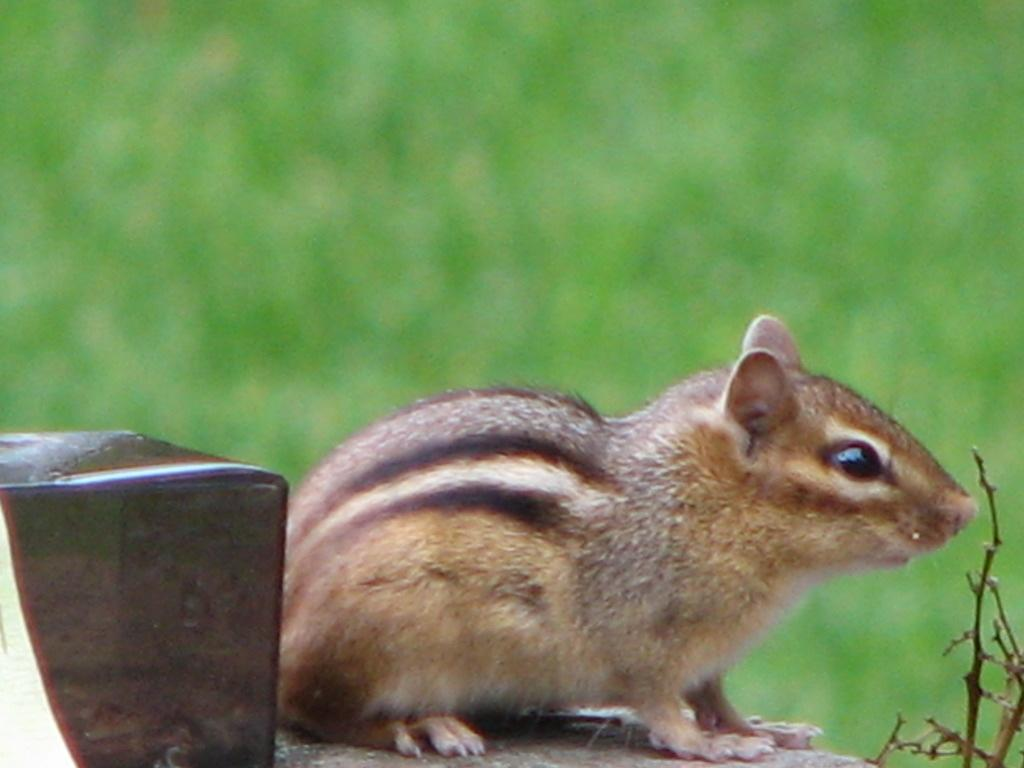What animal is present in the image? There is a squirrel in the image. What is the squirrel's position in the image? The squirrel is on a surface. What can be seen near the squirrel? There is an object beside the squirrel. How would you describe the background of the image? The background of the image is blurred. What time does the clock show in the image? There is no clock present in the image. Can you describe the cat's behavior in the image? There is no cat present in the image. 